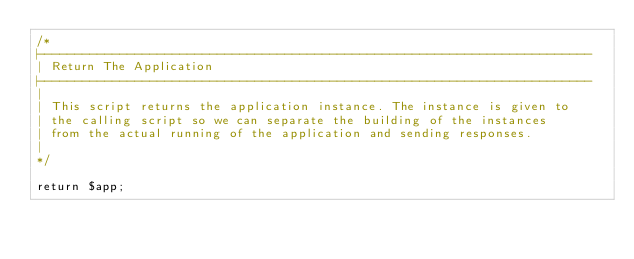<code> <loc_0><loc_0><loc_500><loc_500><_PHP_>/*
|--------------------------------------------------------------------------
| Return The Application
|--------------------------------------------------------------------------
|
| This script returns the application instance. The instance is given to
| the calling script so we can separate the building of the instances
| from the actual running of the application and sending responses.
|
*/

return $app;
</code> 